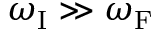<formula> <loc_0><loc_0><loc_500><loc_500>\omega _ { I } \gg \omega _ { F }</formula> 